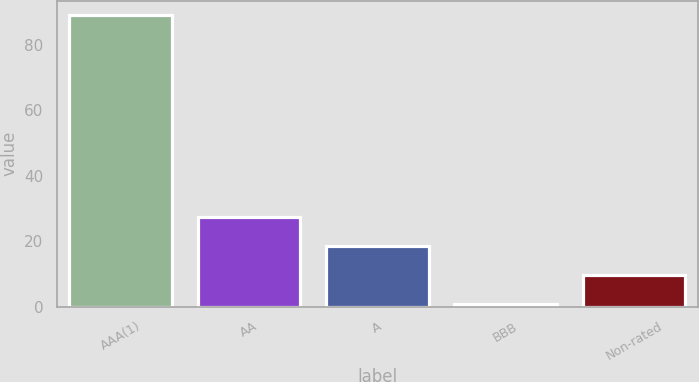Convert chart to OTSL. <chart><loc_0><loc_0><loc_500><loc_500><bar_chart><fcel>AAA(1)<fcel>AA<fcel>A<fcel>BBB<fcel>Non-rated<nl><fcel>89<fcel>27.4<fcel>18.6<fcel>1<fcel>9.8<nl></chart> 